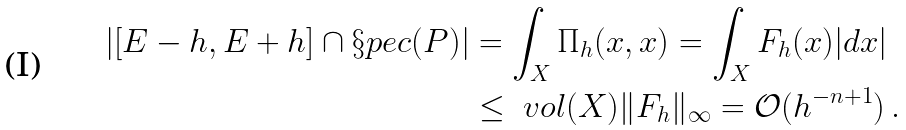<formula> <loc_0><loc_0><loc_500><loc_500>| [ E - h , E + h ] \cap \S p e c ( P ) | & = \int _ { X } \Pi _ { h } ( x , x ) = \int _ { X } F _ { h } ( x ) | d x | \\ & \leq \ v o l ( X ) \| F _ { h } \| _ { \infty } = { \mathcal { O } } ( h ^ { - n + 1 } ) \, .</formula> 